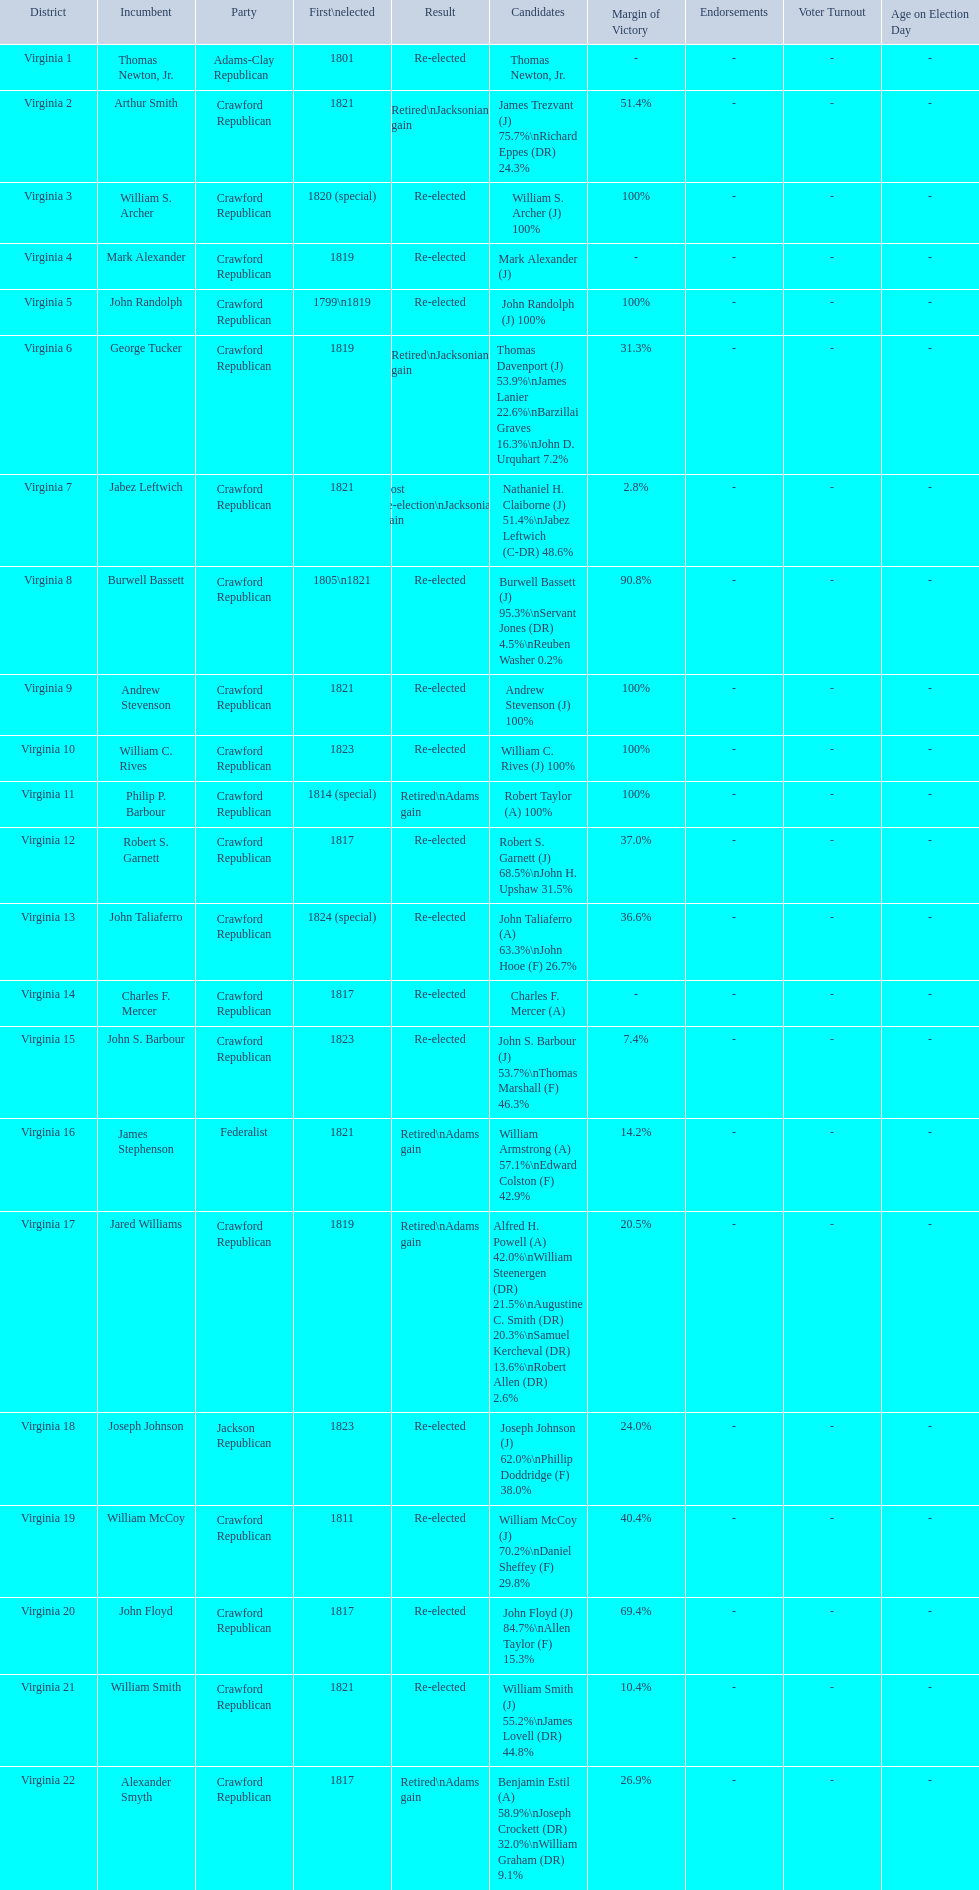Which incumbents belonged to the crawford republican party? Arthur Smith, William S. Archer, Mark Alexander, John Randolph, George Tucker, Jabez Leftwich, Burwell Bassett, Andrew Stevenson, William C. Rives, Philip P. Barbour, Robert S. Garnett, John Taliaferro, Charles F. Mercer, John S. Barbour, Jared Williams, William McCoy, John Floyd, William Smith, Alexander Smyth. Which of these incumbents were first elected in 1821? Arthur Smith, Jabez Leftwich, Andrew Stevenson, William Smith. Which of these incumbents have a last name of smith? Arthur Smith, William Smith. Which of these two were not re-elected? Arthur Smith. 